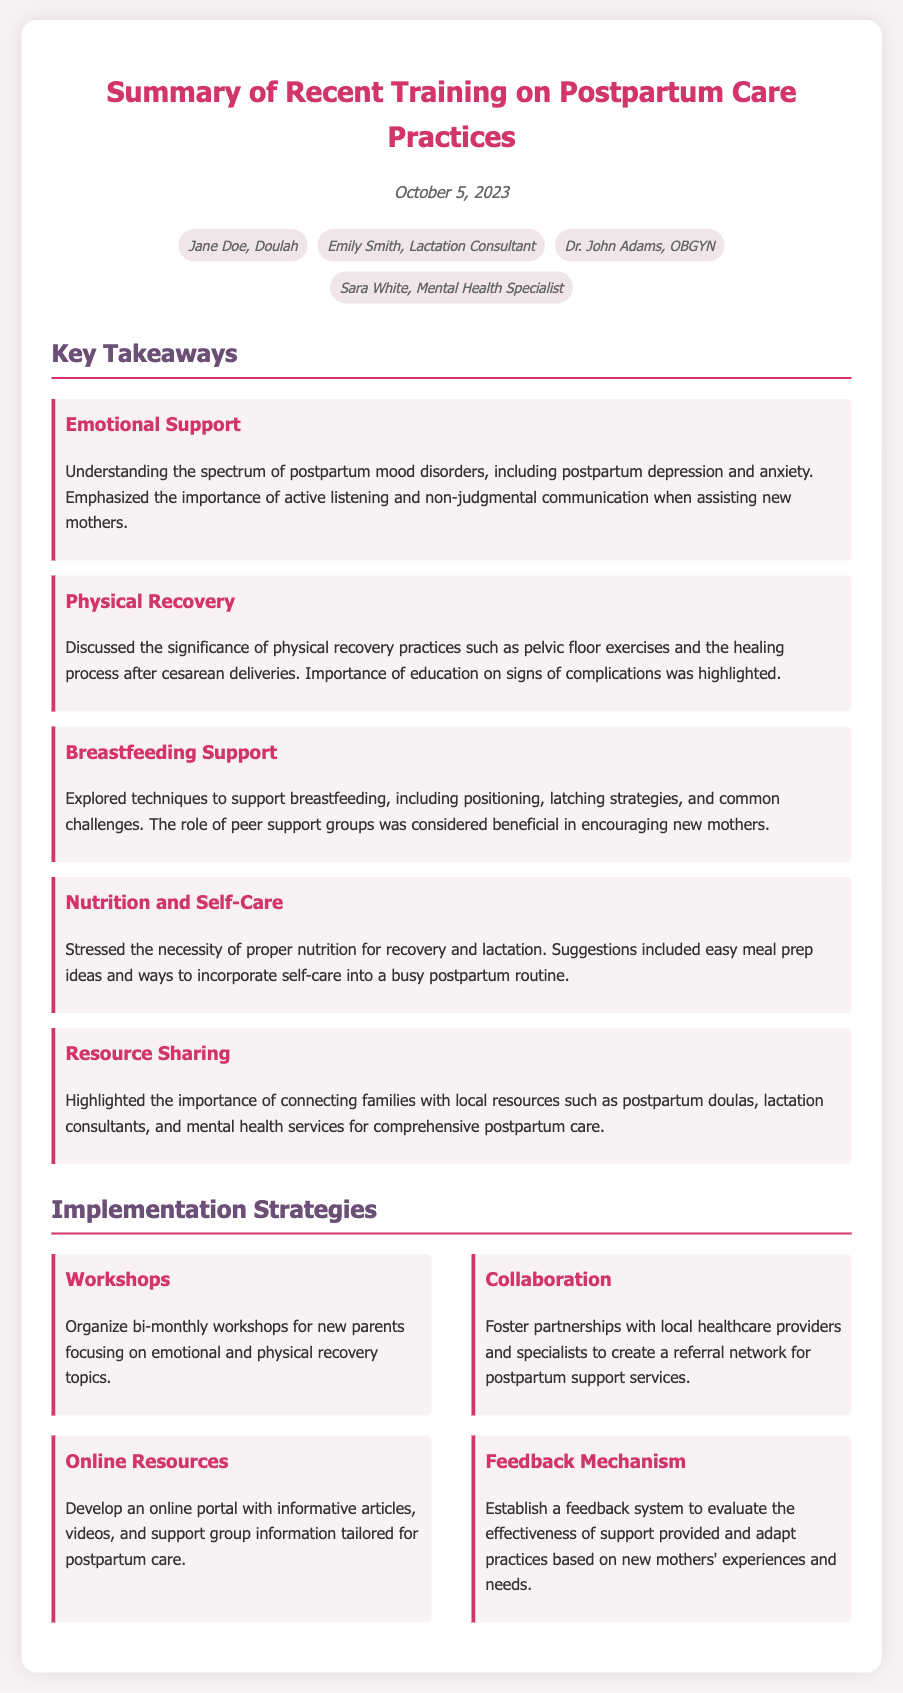What is the date of the training summary? The date is mentioned clearly at the top of the document.
Answer: October 5, 2023 Who is the lactation consultant in attendance? The attendees' names are listed in the document, highlighting their roles.
Answer: Emily Smith What is one key takeaway regarding emotional support? The document summarizes key takeaways including emotional support practices.
Answer: Understanding the spectrum of postpartum mood disorders How many implementation strategies are listed? The implementation strategies are gathered under a distinct section in the document.
Answer: Four What is one suggested implementation strategy? Specific implementation strategies are provided for actionable support.
Answer: Organize bi-monthly workshops What is a focus of the physical recovery discussion? The key takeaway sections outline specific topics covered in the training.
Answer: Pelvic floor exercises What role do peer support groups play according to the document? The discussion of breastfeeding support mentions specific beneficial practices.
Answer: Encouraging new mothers Who presented the training? The attendees also imply who was involved in the training preparation.
Answer: Not explicitly stated in the document 